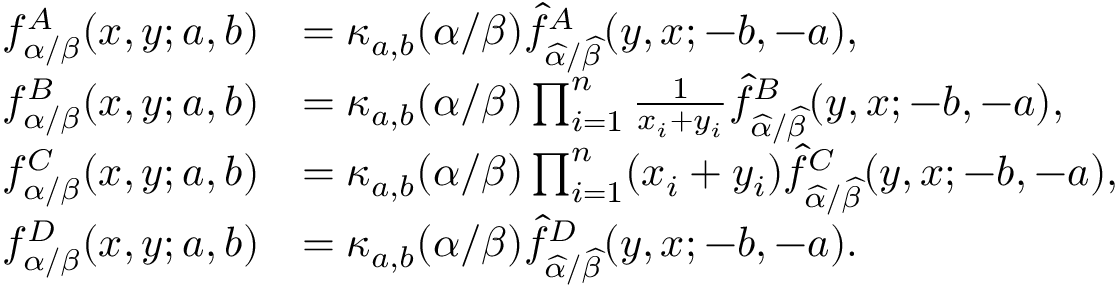Convert formula to latex. <formula><loc_0><loc_0><loc_500><loc_500>\begin{array} { r l } { f _ { \alpha / \beta } ^ { A } ( x , y ; a , b ) } & { = \kappa _ { a , b } ( \alpha / \beta ) \widehat { f } _ { \widehat { \alpha } / \widehat { \beta } } ^ { A } ( y , x ; - b , - a ) , } \\ { f _ { \alpha / \beta } ^ { B } ( x , y ; a , b ) } & { = \kappa _ { a , b } ( \alpha / \beta ) \prod _ { i = 1 } ^ { n } \frac { 1 } { x _ { i } + y _ { i } } \widehat { f } _ { \widehat { \alpha } / \widehat { \beta } } ^ { B } ( y , x ; - b , - a ) , } \\ { f _ { \alpha / \beta } ^ { C } ( x , y ; a , b ) } & { = \kappa _ { a , b } ( \alpha / \beta ) \prod _ { i = 1 } ^ { n } ( x _ { i } + y _ { i } ) \widehat { f } _ { \widehat { \alpha } / \widehat { \beta } } ^ { C } ( y , x ; - b , - a ) , } \\ { f _ { \alpha / \beta } ^ { D } ( x , y ; a , b ) } & { = \kappa _ { a , b } ( \alpha / \beta ) \widehat { f } _ { \widehat { \alpha } / \widehat { \beta } } ^ { D } ( y , x ; - b , - a ) . } \end{array}</formula> 